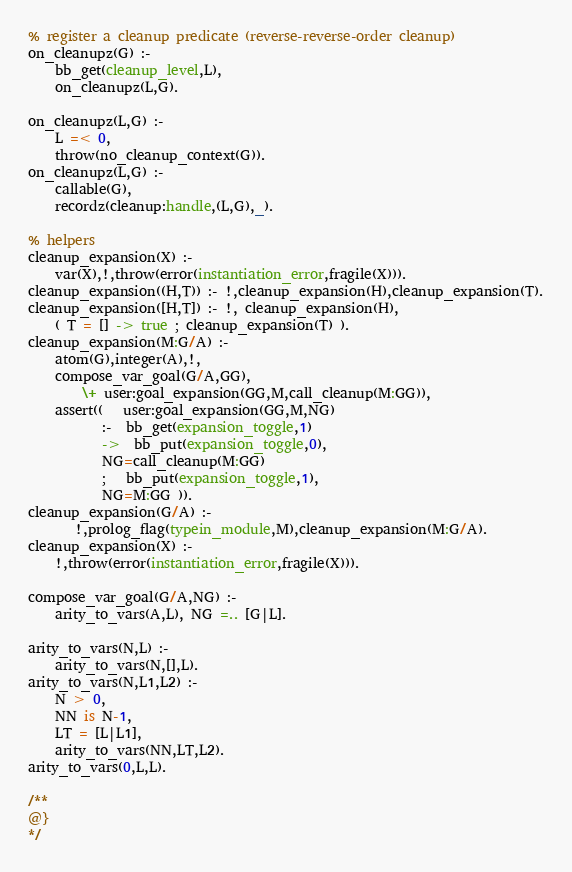<code> <loc_0><loc_0><loc_500><loc_500><_Prolog_>

% register a cleanup predicate (reverse-reverse-order cleanup)
on_cleanupz(G) :-
	bb_get(cleanup_level,L),
	on_cleanupz(L,G).

on_cleanupz(L,G) :-
	L =< 0,
	throw(no_cleanup_context(G)).
on_cleanupz(L,G) :-
	callable(G),
	recordz(cleanup:handle,(L,G),_).

% helpers
cleanup_expansion(X) :-
	var(X),!,throw(error(instantiation_error,fragile(X))).
cleanup_expansion((H,T)) :- !,cleanup_expansion(H),cleanup_expansion(T).
cleanup_expansion([H,T]) :- !, cleanup_expansion(H),
	( T = [] -> true ; cleanup_expansion(T) ).
cleanup_expansion(M:G/A) :-
 	atom(G),integer(A),!,
	compose_var_goal(G/A,GG),
        \+ user:goal_expansion(GG,M,call_cleanup(M:GG)),
	assert((   user:goal_expansion(GG,M,NG)
	       :-  bb_get(expansion_toggle,1)
	       ->  bb_put(expansion_toggle,0),
		   NG=call_cleanup(M:GG)
	       ;   bb_put(expansion_toggle,1),
		   NG=M:GG )).
cleanup_expansion(G/A) :-
       !,prolog_flag(typein_module,M),cleanup_expansion(M:G/A).
cleanup_expansion(X) :-
	!,throw(error(instantiation_error,fragile(X))).

compose_var_goal(G/A,NG) :-
	arity_to_vars(A,L), NG =.. [G|L].

arity_to_vars(N,L) :-
	arity_to_vars(N,[],L).
arity_to_vars(N,L1,L2) :-
	N > 0,
	NN is N-1,
	LT = [L|L1],
	arity_to_vars(NN,LT,L2).
arity_to_vars(0,L,L).

/**
@}
*/
</code> 